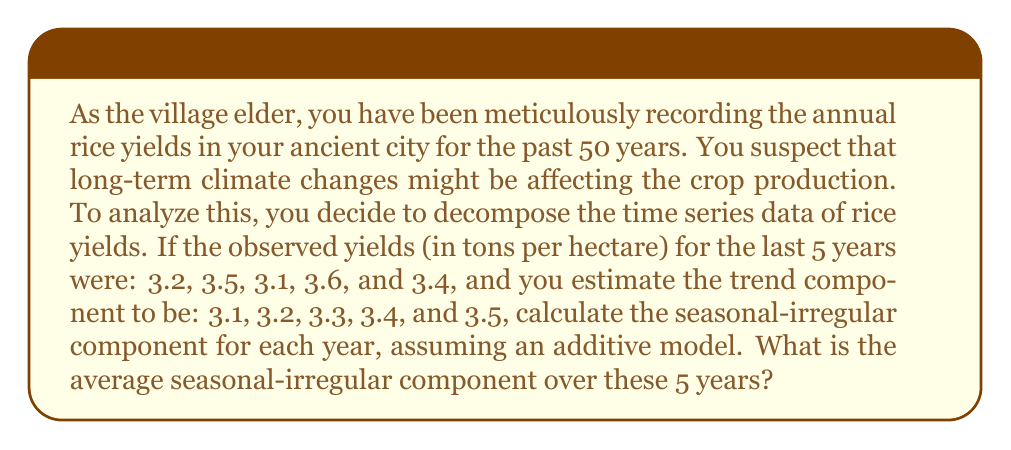Show me your answer to this math problem. To solve this problem, we need to follow these steps:

1) First, recall that in an additive time series model, we have:

   $$Y_t = T_t + S_t + I_t$$

   Where $Y_t$ is the observed value, $T_t$ is the trend component, and $(S_t + I_t)$ is the combined seasonal-irregular component.

2) To find the seasonal-irregular component, we subtract the trend from the observed values:

   $$(S_t + I_t) = Y_t - T_t$$

3) Let's calculate this for each year:

   Year 1: $3.2 - 3.1 = 0.1$
   Year 2: $3.5 - 3.2 = 0.3$
   Year 3: $3.1 - 3.3 = -0.2$
   Year 4: $3.6 - 3.4 = 0.2$
   Year 5: $3.4 - 3.5 = -0.1$

4) Now we have the seasonal-irregular components for each year: 0.1, 0.3, -0.2, 0.2, -0.1

5) To find the average, we sum these values and divide by the number of years:

   $$\text{Average} = \frac{0.1 + 0.3 + (-0.2) + 0.2 + (-0.1)}{5} = \frac{0.3}{5} = 0.06$$

Thus, the average seasonal-irregular component over these 5 years is 0.06 tons per hectare.
Answer: 0.06 tons per hectare 